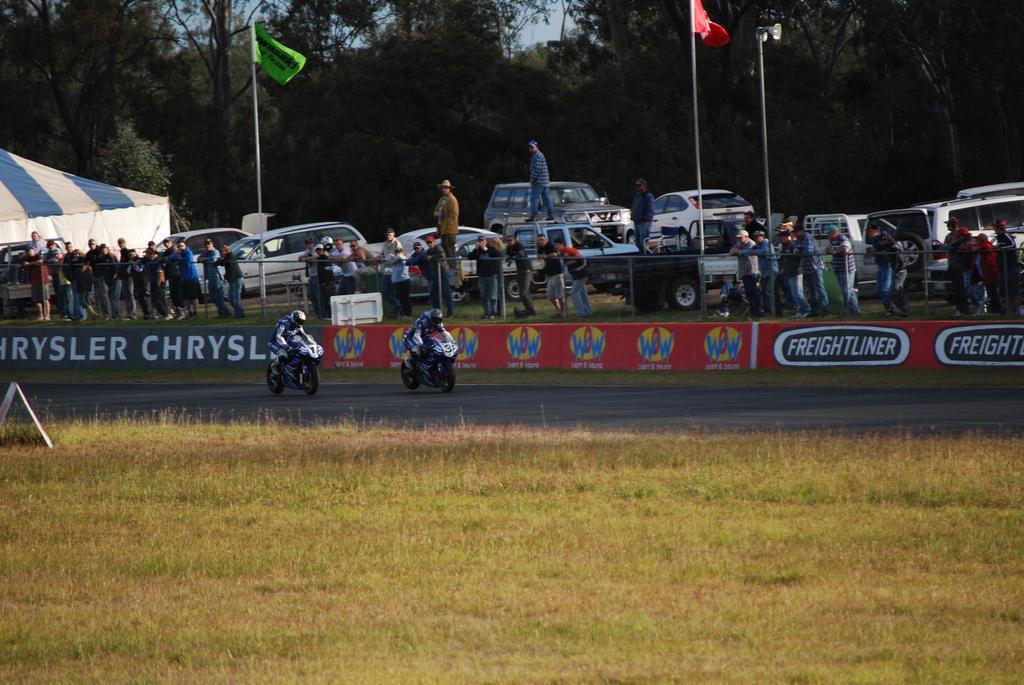Could you give a brief overview of what you see in this image? In the picture we can see a grass surface near it we can see a road with two bikers with a sports bike and behind them we can see a wall with advertisements and in the background we can see some people are standing besides we can see cars, poles with flags, trees and sky. 